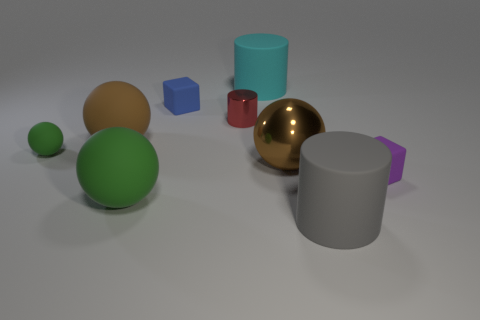Subtract all metal spheres. How many spheres are left? 3 Subtract all cyan cylinders. How many cylinders are left? 2 Subtract all cylinders. How many objects are left? 6 Subtract 3 spheres. How many spheres are left? 1 Add 1 blue blocks. How many objects exist? 10 Subtract all purple blocks. Subtract all red spheres. How many blocks are left? 1 Add 2 big brown matte balls. How many big brown matte balls are left? 3 Add 1 tiny purple blocks. How many tiny purple blocks exist? 2 Subtract 0 yellow cylinders. How many objects are left? 9 Subtract all cyan cylinders. How many cyan cubes are left? 0 